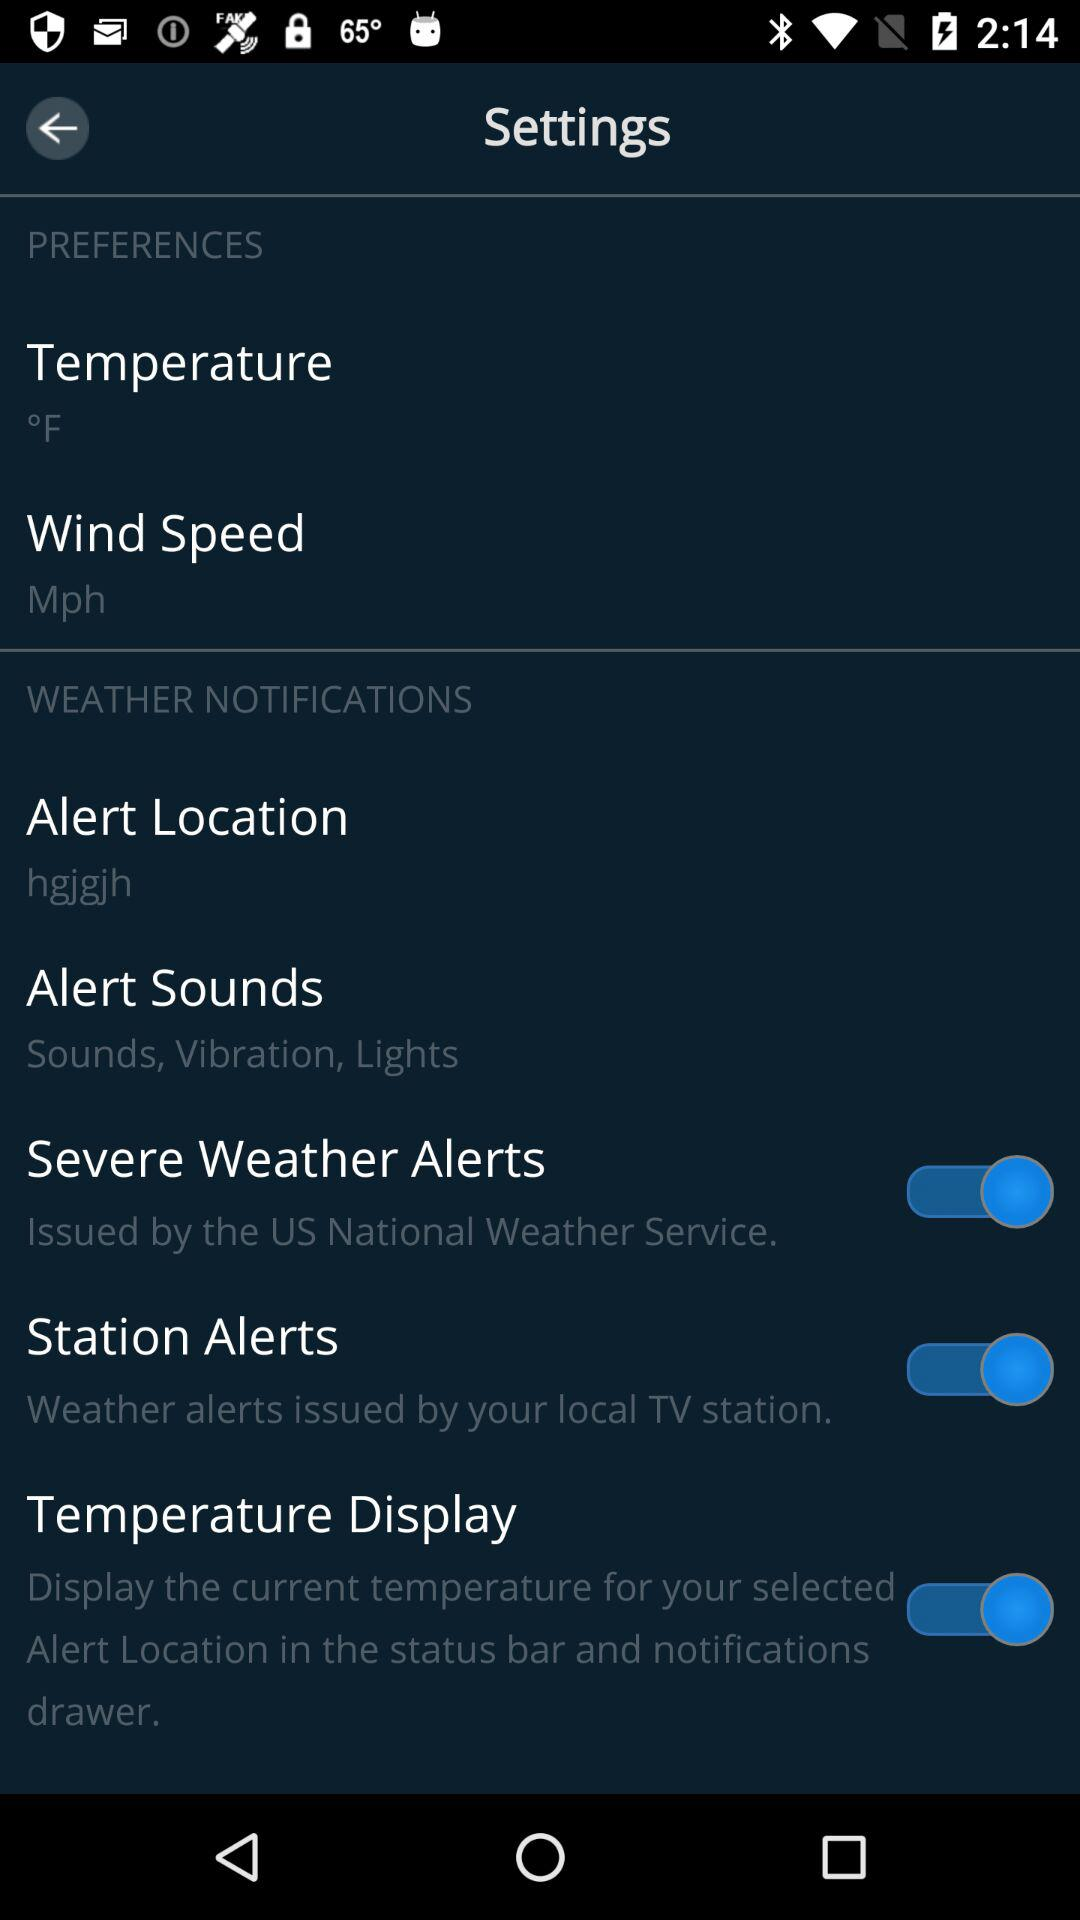What is the unit of temperature? The unit of temperature is Fahrenheit. 